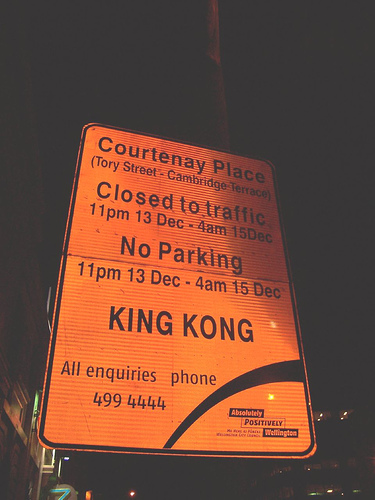<image>
Can you confirm if the sign is in front of the sky? Yes. The sign is positioned in front of the sky, appearing closer to the camera viewpoint. 